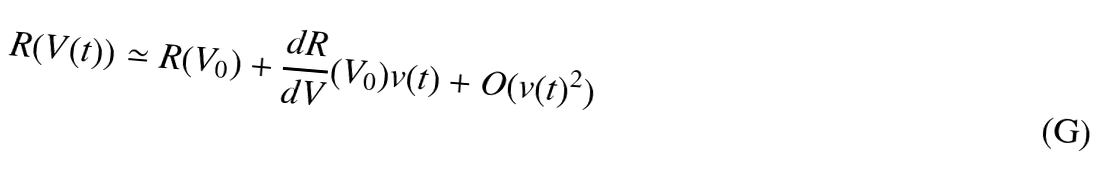Convert formula to latex. <formula><loc_0><loc_0><loc_500><loc_500>R ( V ( t ) ) \simeq R ( V _ { 0 } ) + \frac { d R } { d V } ( V _ { 0 } ) v ( t ) + O ( v ( t ) ^ { 2 } )</formula> 